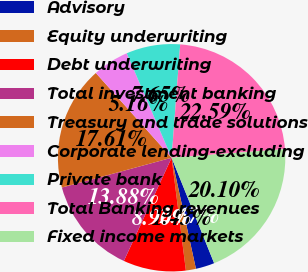<chart> <loc_0><loc_0><loc_500><loc_500><pie_chart><fcel>Advisory<fcel>Equity underwriting<fcel>Debt underwriting<fcel>Total investment banking<fcel>Treasury and trade solutions<fcel>Corporate lending-excluding<fcel>Private bank<fcel>Total Banking revenues<fcel>Fixed income markets<nl><fcel>2.67%<fcel>1.43%<fcel>8.9%<fcel>13.88%<fcel>17.61%<fcel>5.16%<fcel>7.65%<fcel>22.59%<fcel>20.1%<nl></chart> 